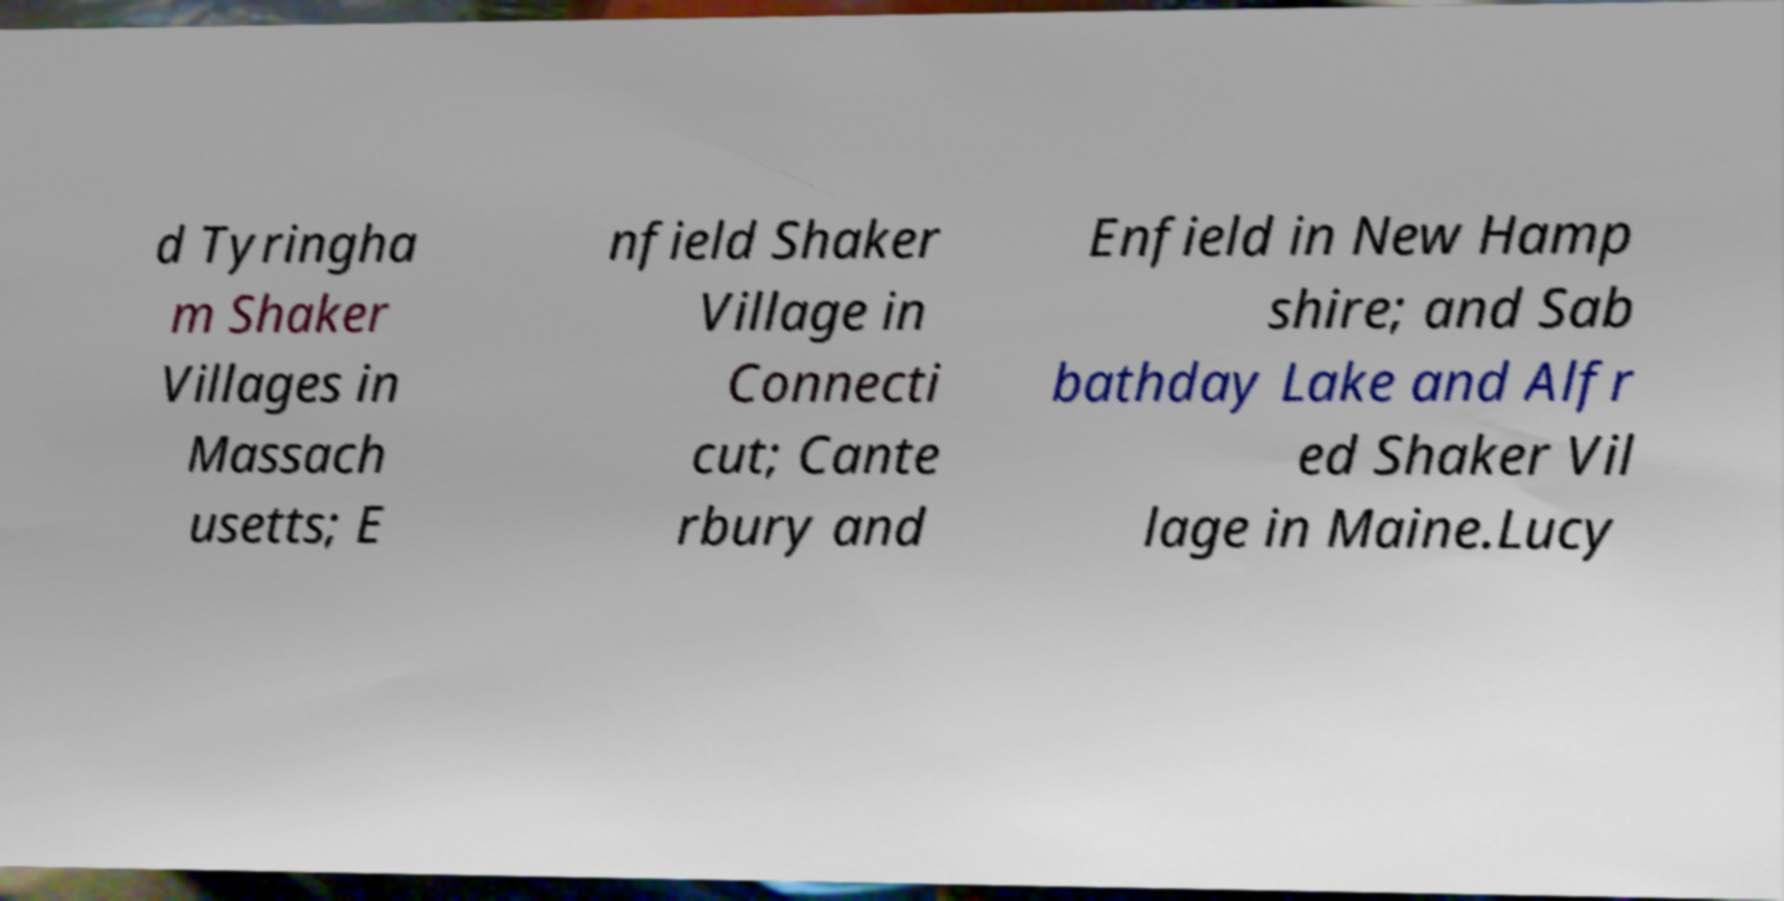What messages or text are displayed in this image? I need them in a readable, typed format. d Tyringha m Shaker Villages in Massach usetts; E nfield Shaker Village in Connecti cut; Cante rbury and Enfield in New Hamp shire; and Sab bathday Lake and Alfr ed Shaker Vil lage in Maine.Lucy 